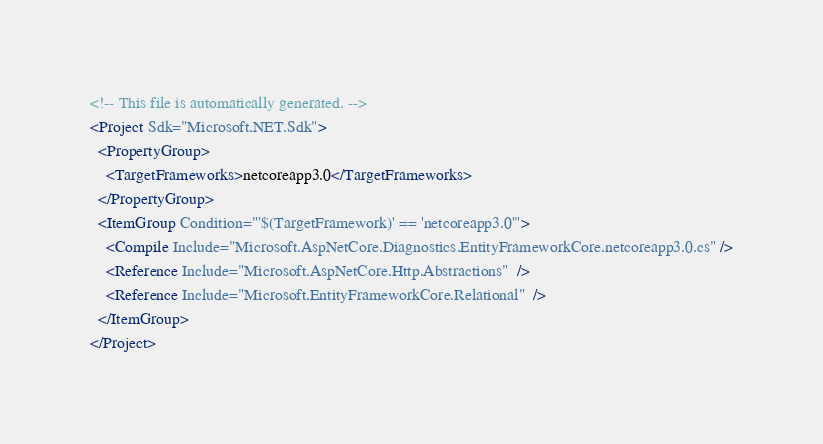<code> <loc_0><loc_0><loc_500><loc_500><_XML_><!-- This file is automatically generated. -->
<Project Sdk="Microsoft.NET.Sdk">
  <PropertyGroup>
    <TargetFrameworks>netcoreapp3.0</TargetFrameworks>
  </PropertyGroup>
  <ItemGroup Condition="'$(TargetFramework)' == 'netcoreapp3.0'">
    <Compile Include="Microsoft.AspNetCore.Diagnostics.EntityFrameworkCore.netcoreapp3.0.cs" />
    <Reference Include="Microsoft.AspNetCore.Http.Abstractions"  />
    <Reference Include="Microsoft.EntityFrameworkCore.Relational"  />
  </ItemGroup>
</Project>
</code> 